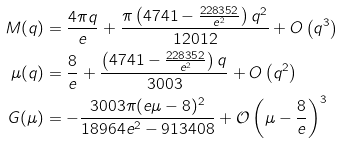<formula> <loc_0><loc_0><loc_500><loc_500>M ( q ) & = \frac { 4 \pi q } { e } + \frac { \pi \left ( 4 7 4 1 - \frac { 2 2 8 3 5 2 } { e ^ { 2 } } \right ) q ^ { 2 } } { 1 2 0 1 2 } + O \left ( q ^ { 3 } \right ) \\ \mu ( q ) & = \frac { 8 } { e } + \frac { \left ( 4 7 4 1 - \frac { 2 2 8 3 5 2 } { e ^ { 2 } } \right ) q } { 3 0 0 3 } + O \left ( q ^ { 2 } \right ) \\ G ( \mu ) & = - \frac { 3 0 0 3 \pi ( e \mu - 8 ) ^ { 2 } } { 1 8 9 6 4 e ^ { 2 } - 9 1 3 4 0 8 } + \mathcal { O } \left ( \mu - \frac { 8 } { e } \right ) ^ { 3 }</formula> 